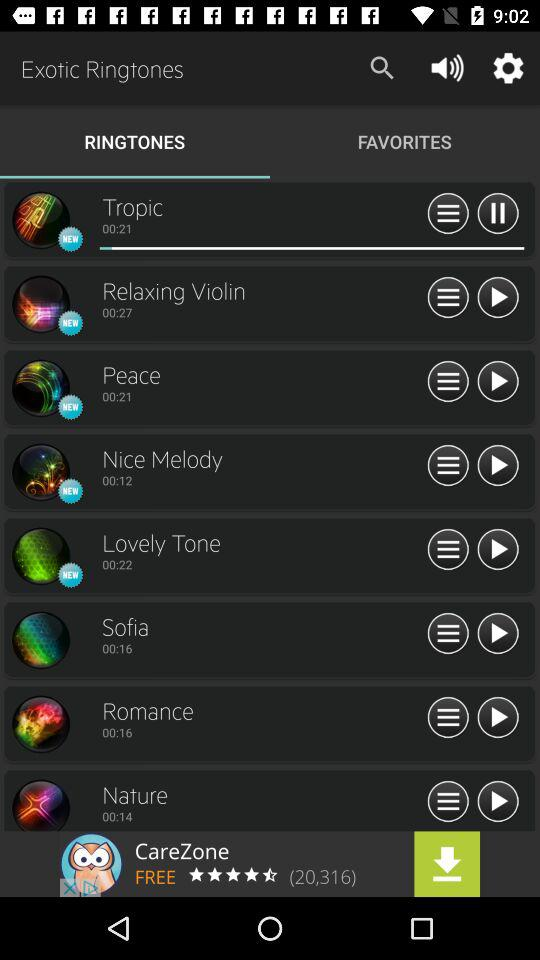Which ringtone is playing on the screen? The ringtone is "Tropic". 